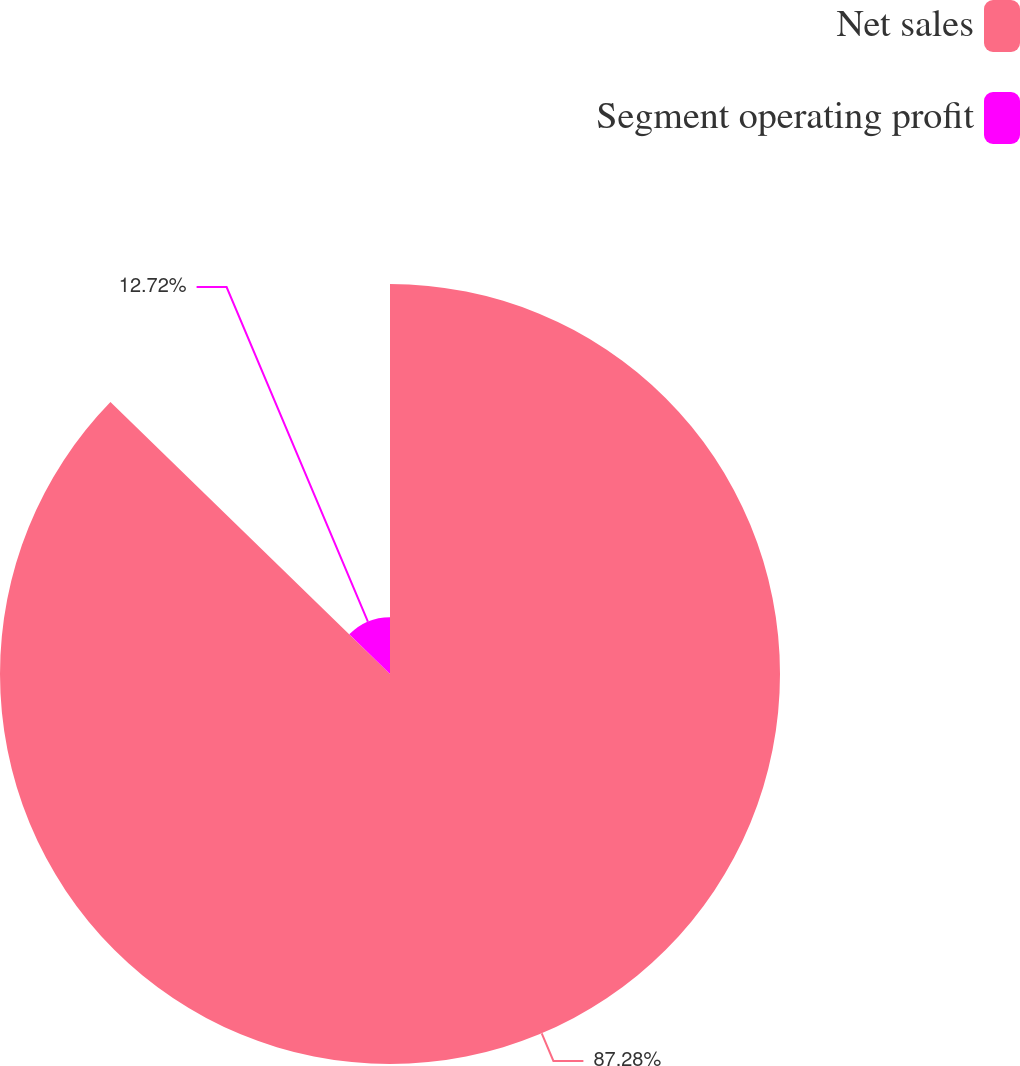Convert chart to OTSL. <chart><loc_0><loc_0><loc_500><loc_500><pie_chart><fcel>Net sales<fcel>Segment operating profit<nl><fcel>87.28%<fcel>12.72%<nl></chart> 